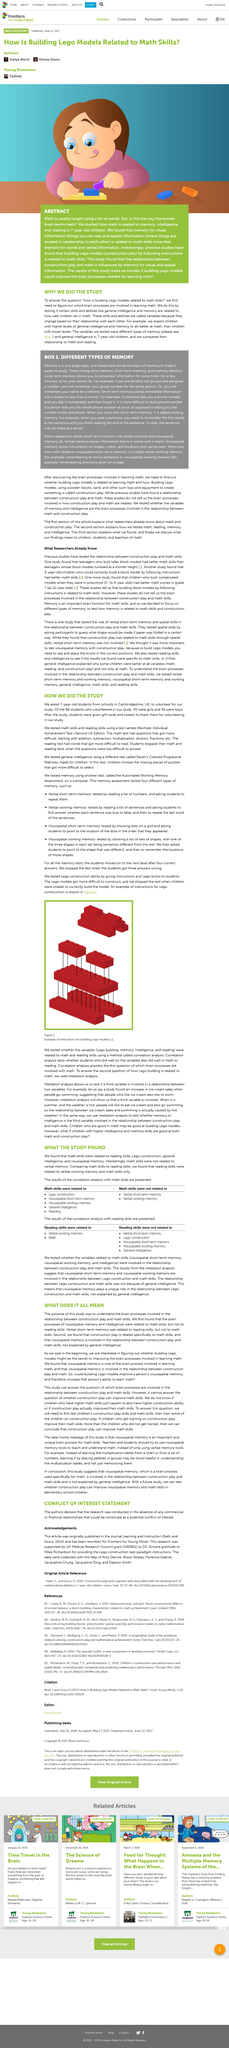Identify some key points in this picture. Meditation analysis allowed for the testing of the relationship between two variables when a third variable is involved. According to the findings of study 5, verbal short-term memory was not involved in the task. In study number 2, the children's age was 3 years old. The study concluded that math skills were found to be related to visiospatial short-term memory. The study did not find a relationship between math skills and verbal short-term memory. 